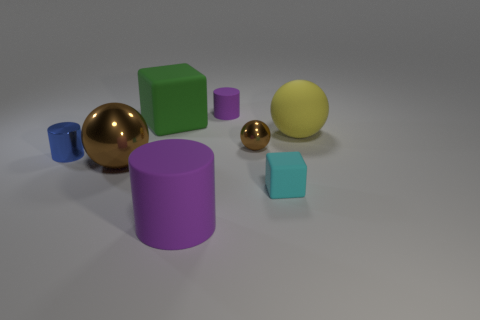Subtract all brown balls. How many were subtracted if there are1brown balls left? 1 Add 1 rubber cylinders. How many objects exist? 9 Subtract 0 yellow cubes. How many objects are left? 8 Subtract all spheres. How many objects are left? 5 Subtract 2 cubes. How many cubes are left? 0 Subtract all brown spheres. Subtract all green cylinders. How many spheres are left? 1 Subtract all green blocks. How many blue spheres are left? 0 Subtract all large brown blocks. Subtract all blue shiny cylinders. How many objects are left? 7 Add 8 big cubes. How many big cubes are left? 9 Add 6 green cubes. How many green cubes exist? 7 